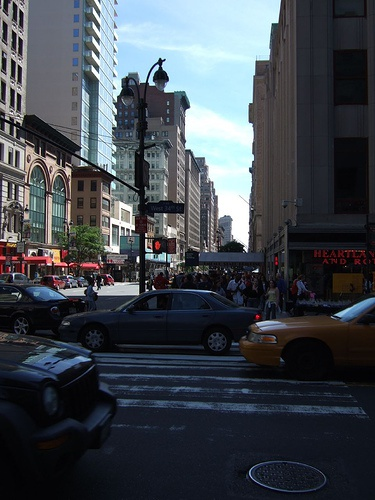Describe the objects in this image and their specific colors. I can see car in purple, black, navy, blue, and gray tones, car in purple, black, navy, and darkblue tones, car in purple, black, and gray tones, car in purple, black, gray, and navy tones, and people in purple, black, navy, gray, and darkblue tones in this image. 